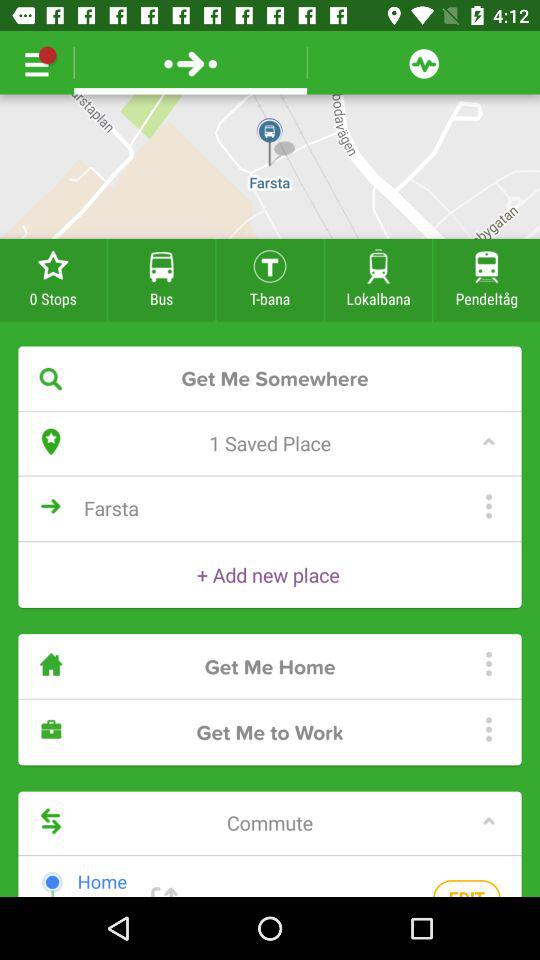How many saved places are there? There is 1 saved place. 